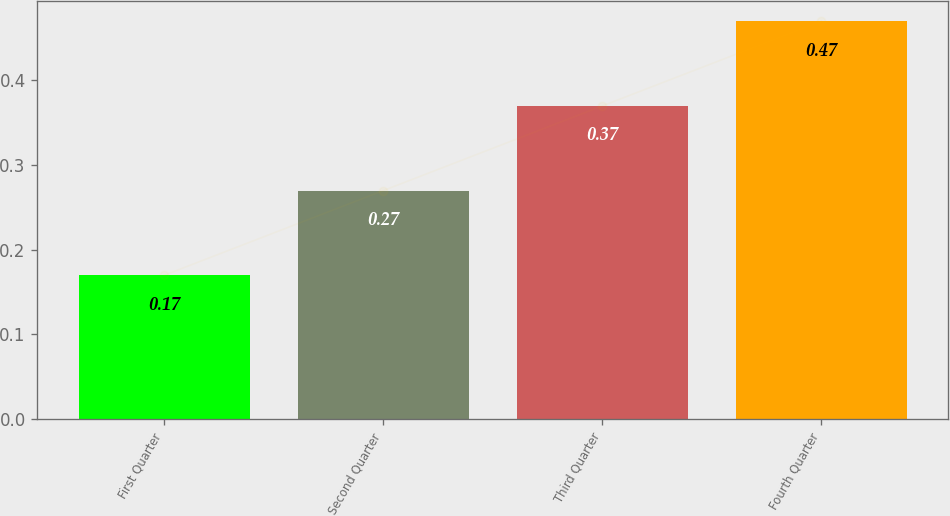<chart> <loc_0><loc_0><loc_500><loc_500><bar_chart><fcel>First Quarter<fcel>Second Quarter<fcel>Third Quarter<fcel>Fourth Quarter<nl><fcel>0.17<fcel>0.27<fcel>0.37<fcel>0.47<nl></chart> 